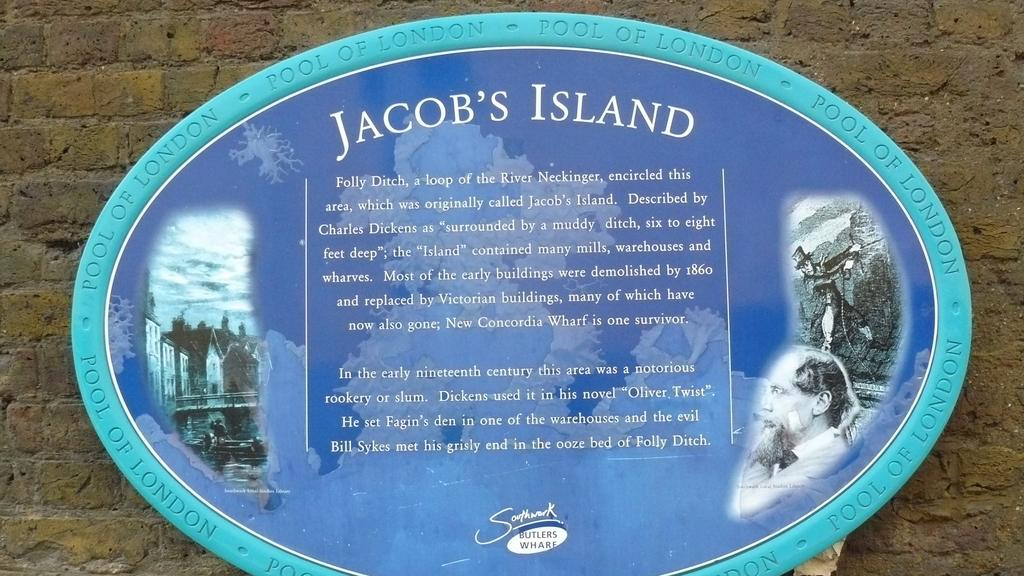What type of structure is visible in the image? There is a brick wall in the image. What is attached to the brick wall? There is an oval shape board on the wall. What can be seen on the board? There are images and writing on the board. What type of yam is being used as a game piece on the board? There is no yam or game present in the image; it features a brick wall with an oval shape board that has images and writing on it. 